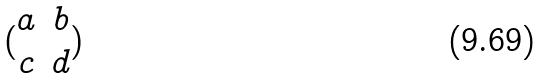<formula> <loc_0><loc_0><loc_500><loc_500>( \begin{matrix} a & b \\ c & d \end{matrix} )</formula> 